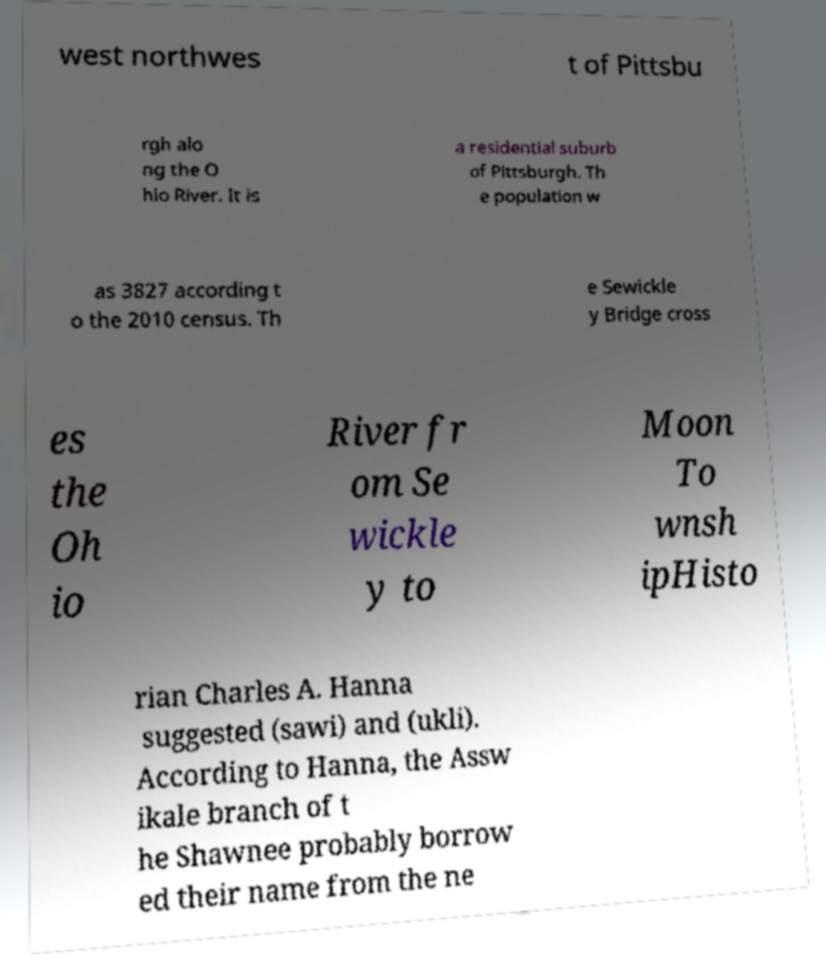Can you read and provide the text displayed in the image?This photo seems to have some interesting text. Can you extract and type it out for me? west northwes t of Pittsbu rgh alo ng the O hio River. It is a residential suburb of Pittsburgh. Th e population w as 3827 according t o the 2010 census. Th e Sewickle y Bridge cross es the Oh io River fr om Se wickle y to Moon To wnsh ipHisto rian Charles A. Hanna suggested (sawi) and (ukli). According to Hanna, the Assw ikale branch of t he Shawnee probably borrow ed their name from the ne 